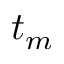<formula> <loc_0><loc_0><loc_500><loc_500>t _ { m }</formula> 